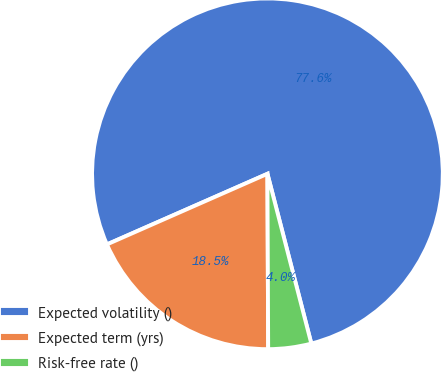Convert chart. <chart><loc_0><loc_0><loc_500><loc_500><pie_chart><fcel>Expected volatility ()<fcel>Expected term (yrs)<fcel>Risk-free rate ()<nl><fcel>77.57%<fcel>18.47%<fcel>3.96%<nl></chart> 